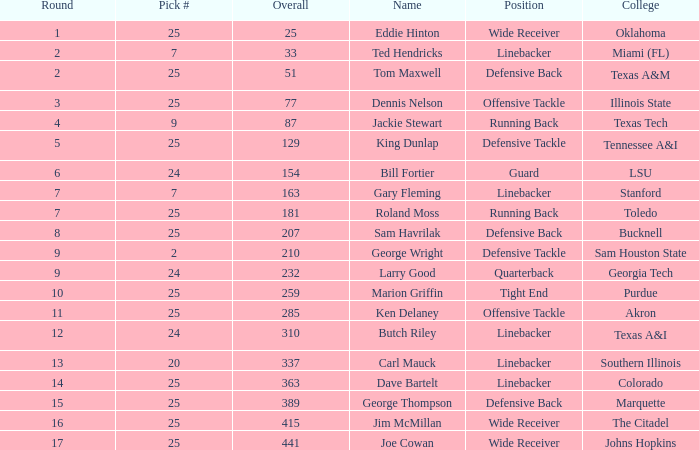Which college has a round less than 7 and an overall score of 129? Tennessee A&I. 